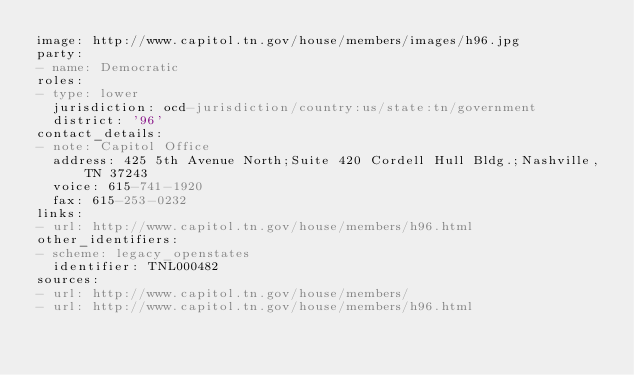<code> <loc_0><loc_0><loc_500><loc_500><_YAML_>image: http://www.capitol.tn.gov/house/members/images/h96.jpg
party:
- name: Democratic
roles:
- type: lower
  jurisdiction: ocd-jurisdiction/country:us/state:tn/government
  district: '96'
contact_details:
- note: Capitol Office
  address: 425 5th Avenue North;Suite 420 Cordell Hull Bldg.;Nashville, TN 37243
  voice: 615-741-1920
  fax: 615-253-0232
links:
- url: http://www.capitol.tn.gov/house/members/h96.html
other_identifiers:
- scheme: legacy_openstates
  identifier: TNL000482
sources:
- url: http://www.capitol.tn.gov/house/members/
- url: http://www.capitol.tn.gov/house/members/h96.html
</code> 